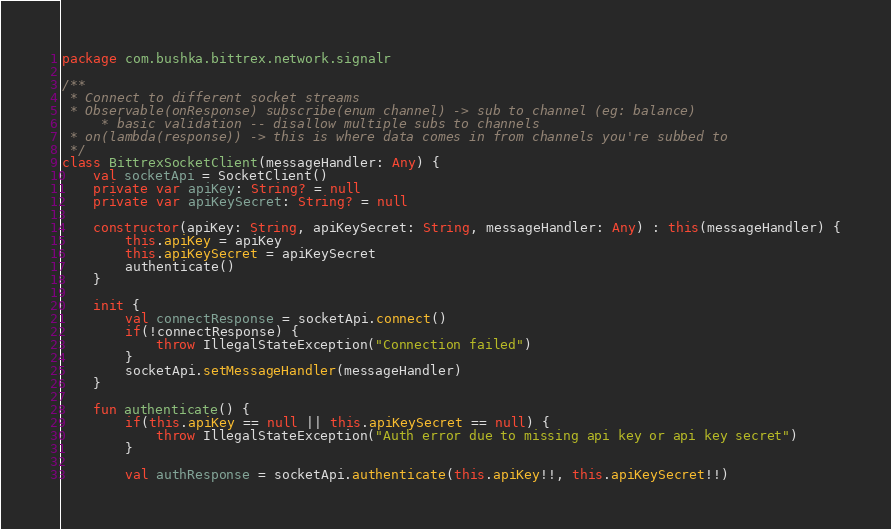Convert code to text. <code><loc_0><loc_0><loc_500><loc_500><_Kotlin_>package com.bushka.bittrex.network.signalr

/**
 * Connect to different socket streams
 * Observable(onResponse) subscribe(enum channel) -> sub to channel (eg: balance)
     * basic validation -- disallow multiple subs to channels
 * on(lambda(response)) -> this is where data comes in from channels you're subbed to
 */
class BittrexSocketClient(messageHandler: Any) {
    val socketApi = SocketClient()
    private var apiKey: String? = null
    private var apiKeySecret: String? = null

    constructor(apiKey: String, apiKeySecret: String, messageHandler: Any) : this(messageHandler) {
        this.apiKey = apiKey
        this.apiKeySecret = apiKeySecret
        authenticate()
    }

    init {
        val connectResponse = socketApi.connect()
        if(!connectResponse) {
            throw IllegalStateException("Connection failed")
        }
        socketApi.setMessageHandler(messageHandler)
    }

    fun authenticate() {
        if(this.apiKey == null || this.apiKeySecret == null) {
            throw IllegalStateException("Auth error due to missing api key or api key secret")
        }

        val authResponse = socketApi.authenticate(this.apiKey!!, this.apiKeySecret!!)</code> 